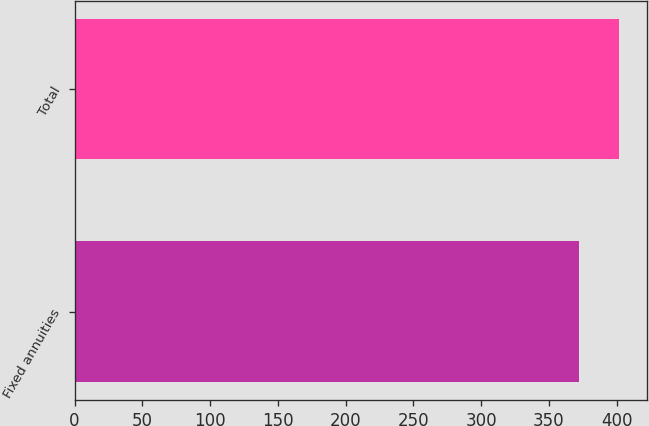Convert chart to OTSL. <chart><loc_0><loc_0><loc_500><loc_500><bar_chart><fcel>Fixed annuities<fcel>Total<nl><fcel>372<fcel>402<nl></chart> 